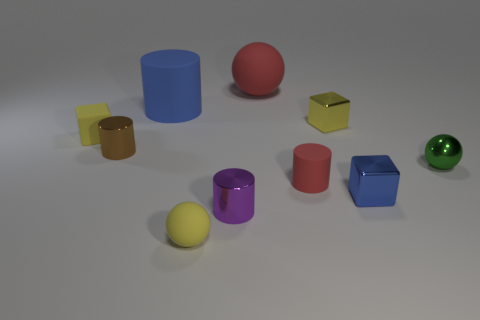Subtract all blue spheres. Subtract all red cubes. How many spheres are left? 3 Subtract all blocks. How many objects are left? 7 Subtract all tiny blue things. Subtract all tiny green metallic balls. How many objects are left? 8 Add 4 tiny yellow matte cubes. How many tiny yellow matte cubes are left? 5 Add 6 small gray matte blocks. How many small gray matte blocks exist? 6 Subtract 1 red balls. How many objects are left? 9 